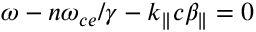<formula> <loc_0><loc_0><loc_500><loc_500>\omega - n \omega _ { c e } / \gamma - k _ { \| } c \beta _ { \| } = 0</formula> 